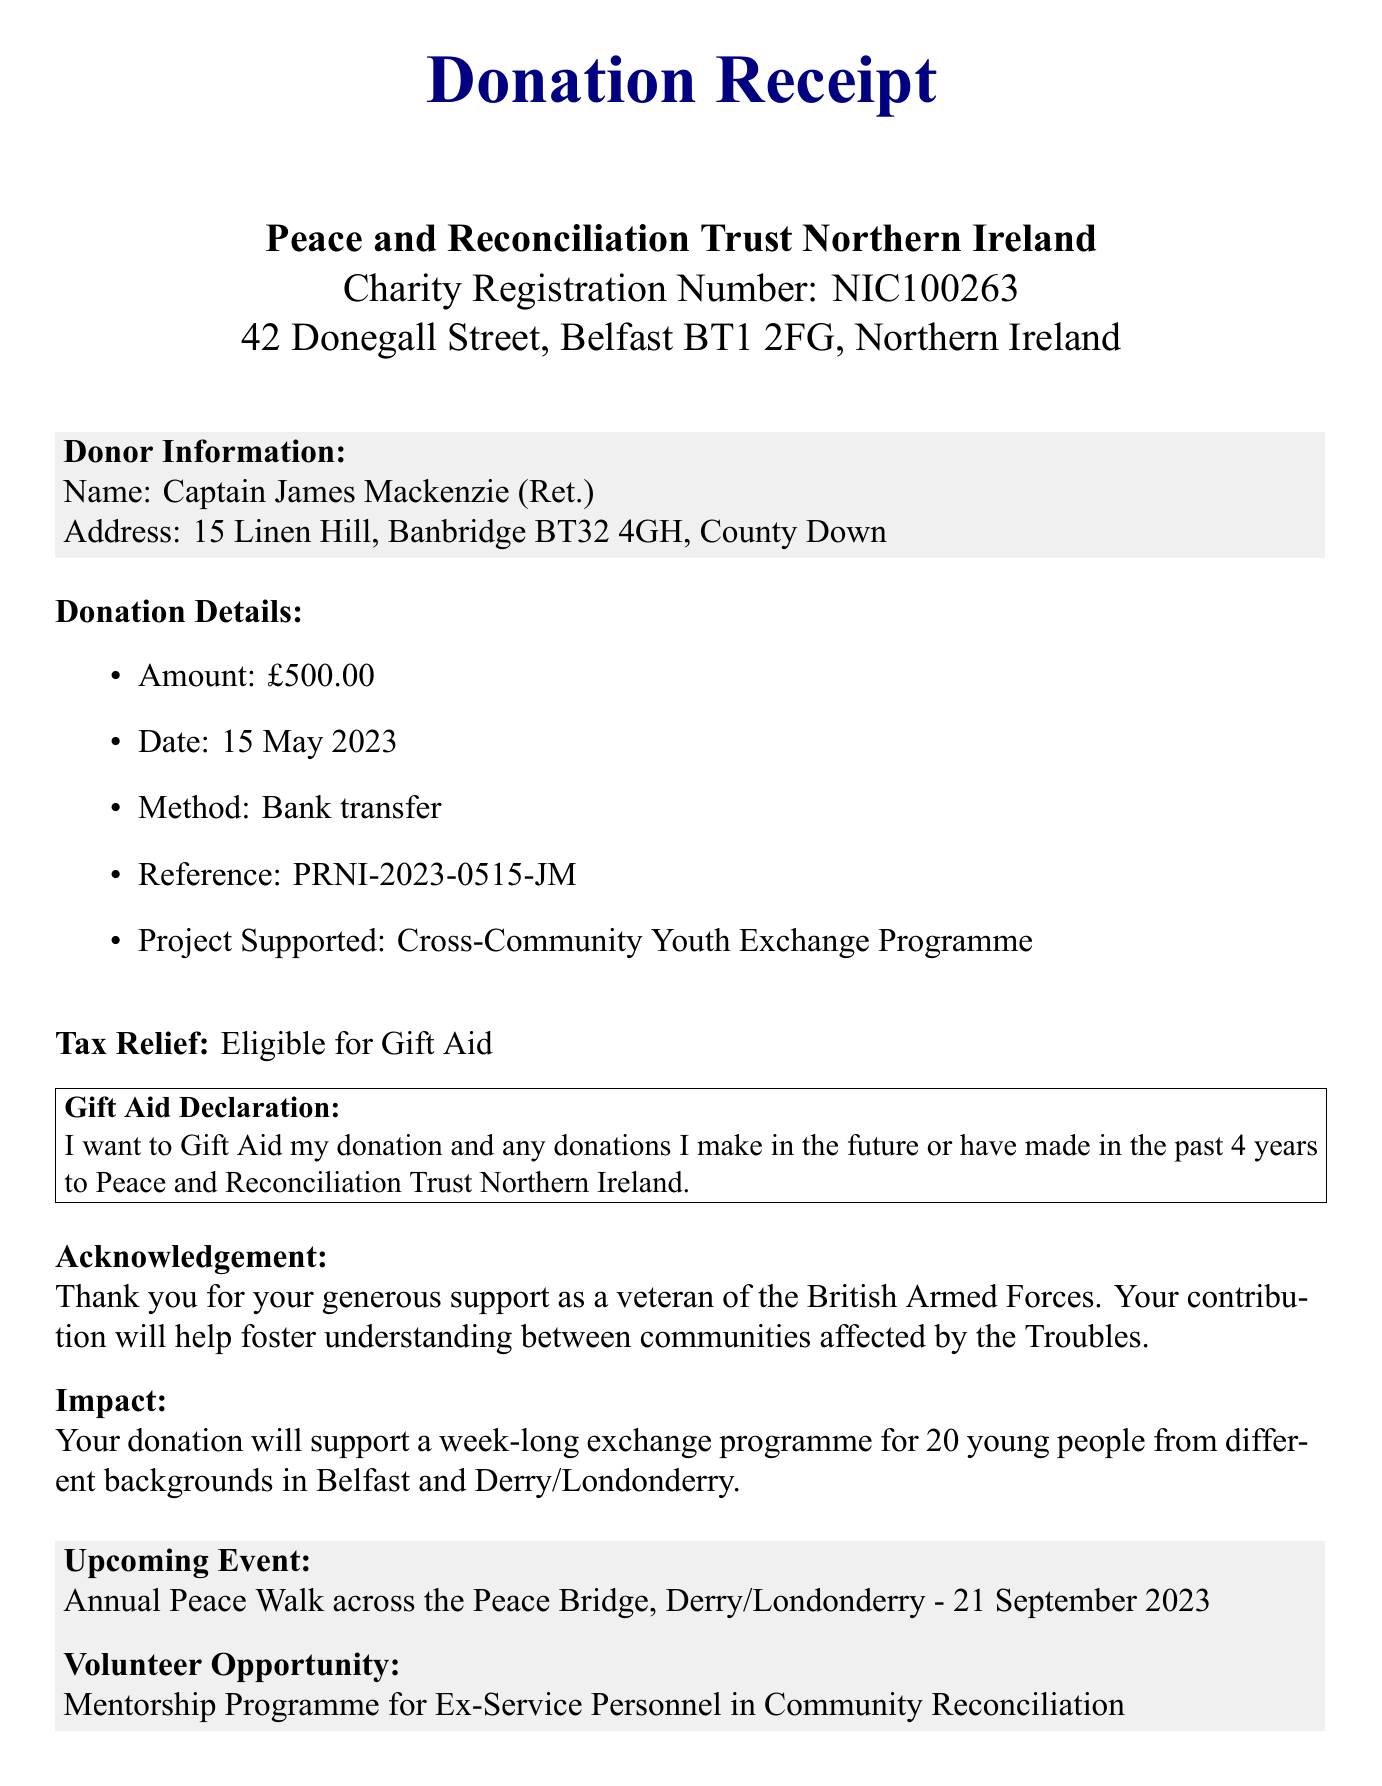what is the donation amount? The donation amount is explicitly stated in the document as £500.00.
Answer: £500.00 who is the donor? The document includes the name of the donor, which is Captain James Mackenzie (Ret.).
Answer: Captain James Mackenzie (Ret.) what is the donation date? The donation date is mentioned in the document, which is 15 May 2023.
Answer: 15 May 2023 which project is supported by the donation? The document specifies the project supported as the Cross-Community Youth Exchange Programme.
Answer: Cross-Community Youth Exchange Programme is the donation eligible for tax relief? The document confirms the eligibility for tax relief as mentioned under the Tax Relief section.
Answer: Eligible for Gift Aid who is the charity director? The name of the charity director is provided in the document, which is Dr. Siobhan O'Neill.
Answer: Dr. Siobhan O'Neill what future event is mentioned in the document? The upcoming event noted is the Annual Peace Walk across the Peace Bridge, on 21 September 2023.
Answer: Annual Peace Walk across the Peace Bridge, Derry/Londonderry - 21 September 2023 what is the method of donation? The document states that the method of donation is a bank transfer.
Answer: Bank transfer what is the charity website? The website of the charity is included in the document for further information.
Answer: www.peaceandreconciliationni.org 